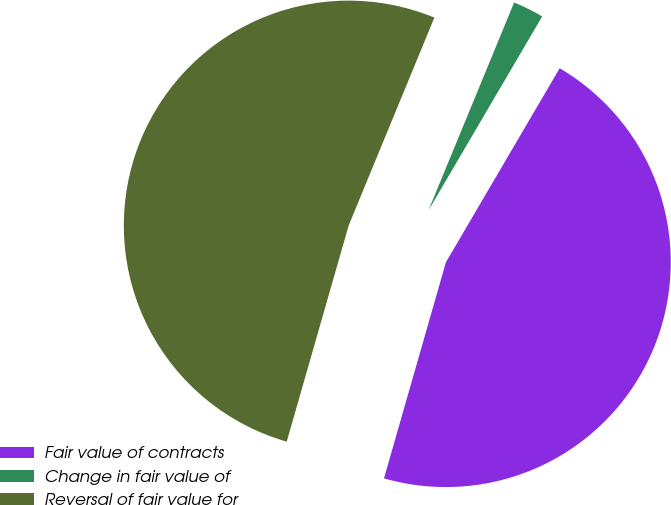<chart> <loc_0><loc_0><loc_500><loc_500><pie_chart><fcel>Fair value of contracts<fcel>Change in fair value of<fcel>Reversal of fair value for<nl><fcel>46.0%<fcel>2.22%<fcel>51.78%<nl></chart> 